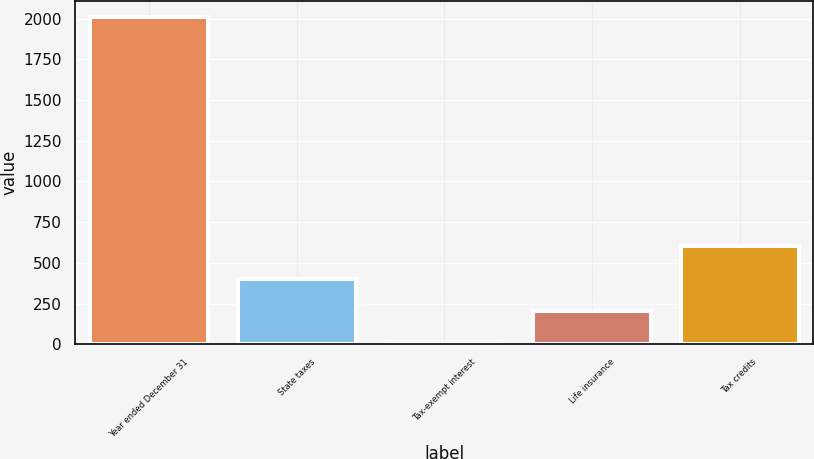<chart> <loc_0><loc_0><loc_500><loc_500><bar_chart><fcel>Year ended December 31<fcel>State taxes<fcel>Tax-exempt interest<fcel>Life insurance<fcel>Tax credits<nl><fcel>2007<fcel>402.04<fcel>0.8<fcel>201.42<fcel>602.66<nl></chart> 